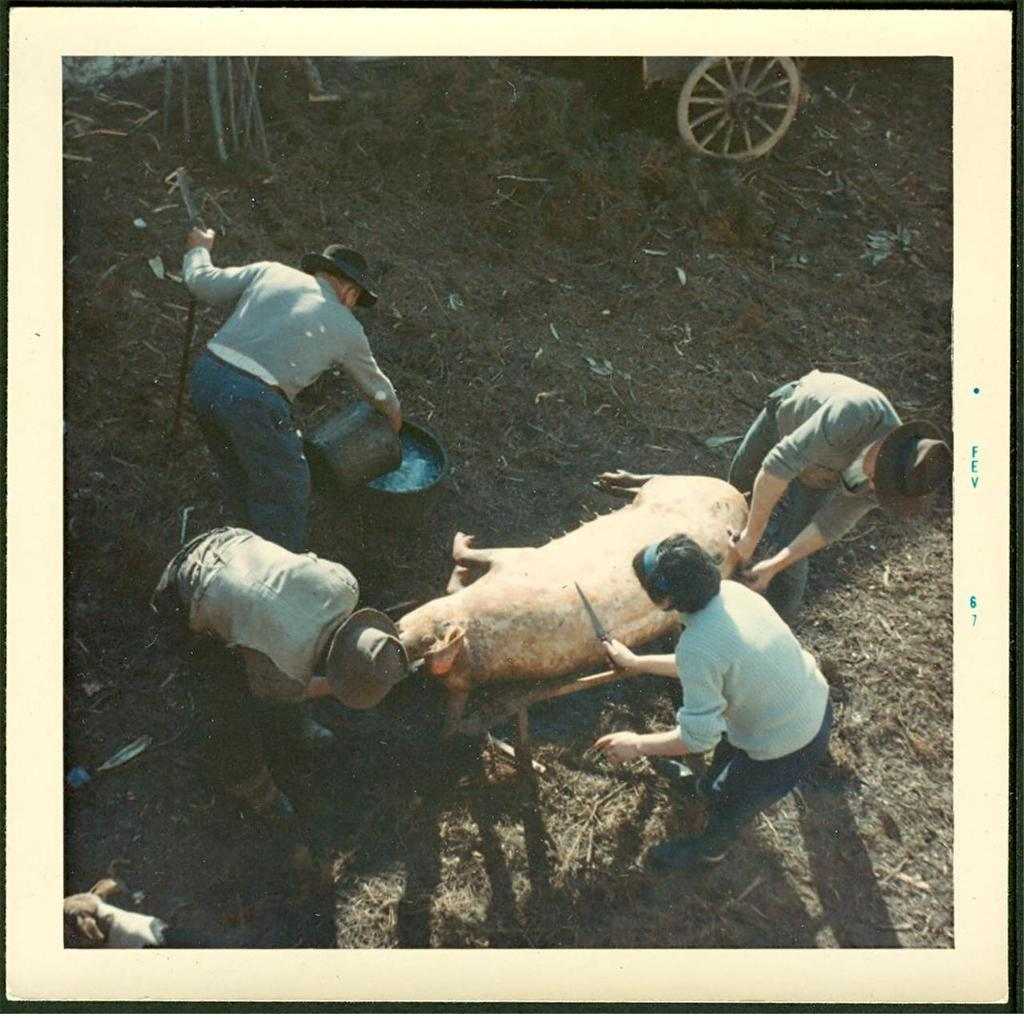How many people are in the image? There are four people in the image. Where are the people located? The people are on a path. What is in front of the people? There is an animal in front of the people. Can you describe any objects in the image? There is a wheel in the image. What can be seen behind the people? There are some items visible behind the people. What arithmetic problem are the people trying to solve in the image? There is no arithmetic problem visible in the image. Can you tell me what the people are arguing about in the image? There is no argument taking place in the image. 